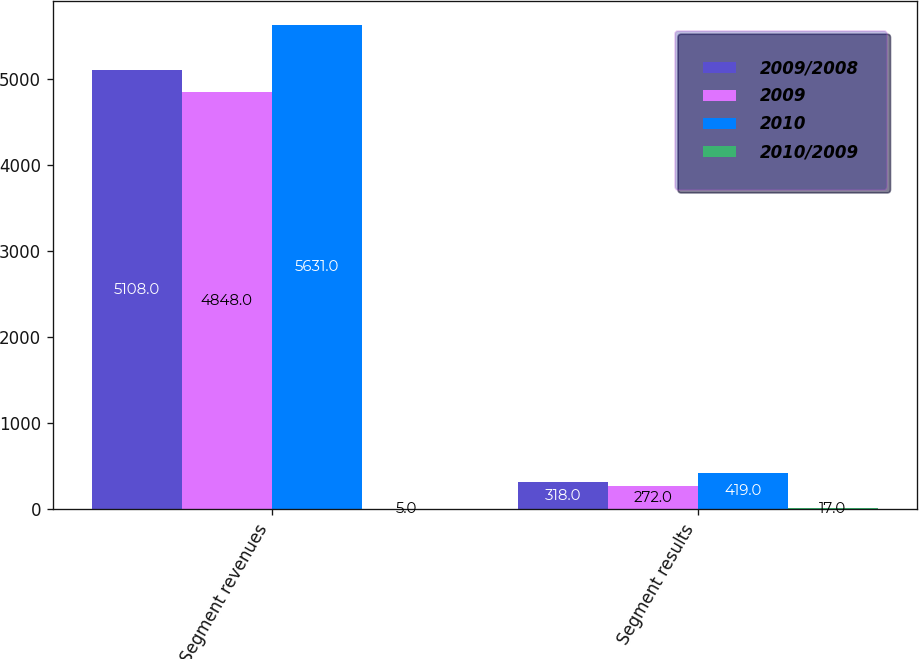Convert chart to OTSL. <chart><loc_0><loc_0><loc_500><loc_500><stacked_bar_chart><ecel><fcel>Segment revenues<fcel>Segment results<nl><fcel>2009/2008<fcel>5108<fcel>318<nl><fcel>2009<fcel>4848<fcel>272<nl><fcel>2010<fcel>5631<fcel>419<nl><fcel>2010/2009<fcel>5<fcel>17<nl></chart> 